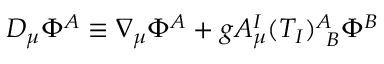<formula> <loc_0><loc_0><loc_500><loc_500>D _ { \mu } \Phi ^ { A } \equiv \nabla _ { \mu } \Phi ^ { A } + g A _ { \mu } ^ { I } ( T _ { I } ) _ { \, B } ^ { A } \Phi ^ { B }</formula> 